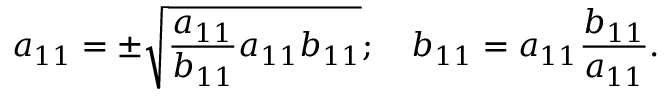<formula> <loc_0><loc_0><loc_500><loc_500>a _ { 1 1 } = \pm \sqrt { \frac { a _ { 1 1 } } { b _ { 1 1 } } a _ { 1 1 } b _ { 1 1 } } ; \quad b _ { 1 1 } = a _ { 1 1 } \frac { b _ { 1 1 } } { a _ { 1 1 } } .</formula> 